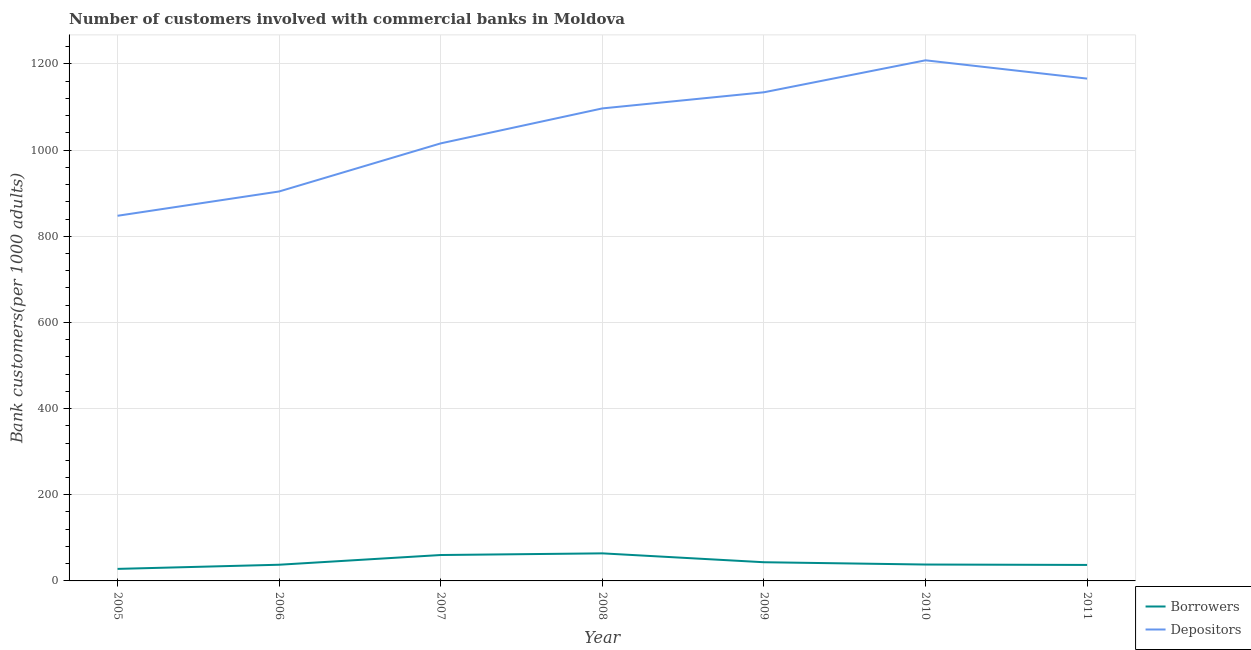How many different coloured lines are there?
Offer a terse response. 2. Does the line corresponding to number of borrowers intersect with the line corresponding to number of depositors?
Ensure brevity in your answer.  No. Is the number of lines equal to the number of legend labels?
Offer a very short reply. Yes. What is the number of borrowers in 2006?
Your answer should be very brief. 37.56. Across all years, what is the maximum number of borrowers?
Ensure brevity in your answer.  63.99. Across all years, what is the minimum number of borrowers?
Your answer should be very brief. 27.94. In which year was the number of depositors maximum?
Provide a short and direct response. 2010. What is the total number of borrowers in the graph?
Your response must be concise. 308.14. What is the difference between the number of depositors in 2007 and that in 2011?
Your response must be concise. -150.33. What is the difference between the number of borrowers in 2006 and the number of depositors in 2008?
Your response must be concise. -1059.17. What is the average number of borrowers per year?
Provide a succinct answer. 44.02. In the year 2007, what is the difference between the number of borrowers and number of depositors?
Your response must be concise. -955.47. In how many years, is the number of depositors greater than 520?
Provide a succinct answer. 7. What is the ratio of the number of depositors in 2006 to that in 2007?
Offer a terse response. 0.89. Is the number of depositors in 2009 less than that in 2010?
Offer a terse response. Yes. Is the difference between the number of borrowers in 2005 and 2010 greater than the difference between the number of depositors in 2005 and 2010?
Your answer should be compact. Yes. What is the difference between the highest and the second highest number of depositors?
Provide a short and direct response. 42.46. What is the difference between the highest and the lowest number of borrowers?
Make the answer very short. 36.05. In how many years, is the number of depositors greater than the average number of depositors taken over all years?
Ensure brevity in your answer.  4. Is the sum of the number of depositors in 2008 and 2010 greater than the maximum number of borrowers across all years?
Ensure brevity in your answer.  Yes. Does the number of depositors monotonically increase over the years?
Offer a terse response. No. Is the number of depositors strictly greater than the number of borrowers over the years?
Offer a very short reply. Yes. Is the number of depositors strictly less than the number of borrowers over the years?
Offer a terse response. No. How many lines are there?
Your response must be concise. 2. Does the graph contain grids?
Your response must be concise. Yes. Where does the legend appear in the graph?
Make the answer very short. Bottom right. How many legend labels are there?
Provide a short and direct response. 2. How are the legend labels stacked?
Your response must be concise. Vertical. What is the title of the graph?
Offer a very short reply. Number of customers involved with commercial banks in Moldova. What is the label or title of the X-axis?
Your response must be concise. Year. What is the label or title of the Y-axis?
Provide a short and direct response. Bank customers(per 1000 adults). What is the Bank customers(per 1000 adults) in Borrowers in 2005?
Make the answer very short. 27.94. What is the Bank customers(per 1000 adults) of Depositors in 2005?
Give a very brief answer. 847.53. What is the Bank customers(per 1000 adults) of Borrowers in 2006?
Offer a very short reply. 37.56. What is the Bank customers(per 1000 adults) in Depositors in 2006?
Your answer should be very brief. 903.95. What is the Bank customers(per 1000 adults) in Borrowers in 2007?
Offer a very short reply. 60.13. What is the Bank customers(per 1000 adults) in Depositors in 2007?
Your answer should be compact. 1015.6. What is the Bank customers(per 1000 adults) in Borrowers in 2008?
Your response must be concise. 63.99. What is the Bank customers(per 1000 adults) of Depositors in 2008?
Offer a terse response. 1096.73. What is the Bank customers(per 1000 adults) of Borrowers in 2009?
Your answer should be compact. 43.38. What is the Bank customers(per 1000 adults) in Depositors in 2009?
Your response must be concise. 1134.17. What is the Bank customers(per 1000 adults) in Borrowers in 2010?
Make the answer very short. 38.03. What is the Bank customers(per 1000 adults) in Depositors in 2010?
Make the answer very short. 1208.39. What is the Bank customers(per 1000 adults) in Borrowers in 2011?
Offer a terse response. 37.11. What is the Bank customers(per 1000 adults) in Depositors in 2011?
Offer a terse response. 1165.93. Across all years, what is the maximum Bank customers(per 1000 adults) in Borrowers?
Offer a very short reply. 63.99. Across all years, what is the maximum Bank customers(per 1000 adults) in Depositors?
Keep it short and to the point. 1208.39. Across all years, what is the minimum Bank customers(per 1000 adults) in Borrowers?
Provide a succinct answer. 27.94. Across all years, what is the minimum Bank customers(per 1000 adults) in Depositors?
Give a very brief answer. 847.53. What is the total Bank customers(per 1000 adults) in Borrowers in the graph?
Provide a succinct answer. 308.14. What is the total Bank customers(per 1000 adults) of Depositors in the graph?
Offer a terse response. 7372.31. What is the difference between the Bank customers(per 1000 adults) of Borrowers in 2005 and that in 2006?
Your answer should be very brief. -9.62. What is the difference between the Bank customers(per 1000 adults) of Depositors in 2005 and that in 2006?
Offer a terse response. -56.41. What is the difference between the Bank customers(per 1000 adults) in Borrowers in 2005 and that in 2007?
Your answer should be very brief. -32.2. What is the difference between the Bank customers(per 1000 adults) in Depositors in 2005 and that in 2007?
Your response must be concise. -168.07. What is the difference between the Bank customers(per 1000 adults) in Borrowers in 2005 and that in 2008?
Your answer should be compact. -36.05. What is the difference between the Bank customers(per 1000 adults) of Depositors in 2005 and that in 2008?
Your answer should be very brief. -249.19. What is the difference between the Bank customers(per 1000 adults) in Borrowers in 2005 and that in 2009?
Offer a terse response. -15.44. What is the difference between the Bank customers(per 1000 adults) of Depositors in 2005 and that in 2009?
Ensure brevity in your answer.  -286.64. What is the difference between the Bank customers(per 1000 adults) of Borrowers in 2005 and that in 2010?
Offer a terse response. -10.1. What is the difference between the Bank customers(per 1000 adults) of Depositors in 2005 and that in 2010?
Provide a succinct answer. -360.86. What is the difference between the Bank customers(per 1000 adults) in Borrowers in 2005 and that in 2011?
Your answer should be very brief. -9.18. What is the difference between the Bank customers(per 1000 adults) of Depositors in 2005 and that in 2011?
Your answer should be very brief. -318.4. What is the difference between the Bank customers(per 1000 adults) in Borrowers in 2006 and that in 2007?
Your answer should be very brief. -22.58. What is the difference between the Bank customers(per 1000 adults) in Depositors in 2006 and that in 2007?
Provide a succinct answer. -111.65. What is the difference between the Bank customers(per 1000 adults) of Borrowers in 2006 and that in 2008?
Provide a succinct answer. -26.43. What is the difference between the Bank customers(per 1000 adults) in Depositors in 2006 and that in 2008?
Your answer should be compact. -192.78. What is the difference between the Bank customers(per 1000 adults) in Borrowers in 2006 and that in 2009?
Your answer should be very brief. -5.82. What is the difference between the Bank customers(per 1000 adults) in Depositors in 2006 and that in 2009?
Make the answer very short. -230.23. What is the difference between the Bank customers(per 1000 adults) in Borrowers in 2006 and that in 2010?
Ensure brevity in your answer.  -0.48. What is the difference between the Bank customers(per 1000 adults) in Depositors in 2006 and that in 2010?
Provide a succinct answer. -304.44. What is the difference between the Bank customers(per 1000 adults) of Borrowers in 2006 and that in 2011?
Offer a terse response. 0.44. What is the difference between the Bank customers(per 1000 adults) of Depositors in 2006 and that in 2011?
Ensure brevity in your answer.  -261.98. What is the difference between the Bank customers(per 1000 adults) in Borrowers in 2007 and that in 2008?
Offer a terse response. -3.86. What is the difference between the Bank customers(per 1000 adults) of Depositors in 2007 and that in 2008?
Your answer should be very brief. -81.13. What is the difference between the Bank customers(per 1000 adults) in Borrowers in 2007 and that in 2009?
Your answer should be compact. 16.76. What is the difference between the Bank customers(per 1000 adults) in Depositors in 2007 and that in 2009?
Give a very brief answer. -118.57. What is the difference between the Bank customers(per 1000 adults) in Borrowers in 2007 and that in 2010?
Your response must be concise. 22.1. What is the difference between the Bank customers(per 1000 adults) in Depositors in 2007 and that in 2010?
Offer a very short reply. -192.79. What is the difference between the Bank customers(per 1000 adults) of Borrowers in 2007 and that in 2011?
Give a very brief answer. 23.02. What is the difference between the Bank customers(per 1000 adults) of Depositors in 2007 and that in 2011?
Your response must be concise. -150.33. What is the difference between the Bank customers(per 1000 adults) of Borrowers in 2008 and that in 2009?
Offer a very short reply. 20.61. What is the difference between the Bank customers(per 1000 adults) in Depositors in 2008 and that in 2009?
Ensure brevity in your answer.  -37.44. What is the difference between the Bank customers(per 1000 adults) of Borrowers in 2008 and that in 2010?
Provide a succinct answer. 25.95. What is the difference between the Bank customers(per 1000 adults) in Depositors in 2008 and that in 2010?
Keep it short and to the point. -111.66. What is the difference between the Bank customers(per 1000 adults) in Borrowers in 2008 and that in 2011?
Your response must be concise. 26.87. What is the difference between the Bank customers(per 1000 adults) in Depositors in 2008 and that in 2011?
Make the answer very short. -69.2. What is the difference between the Bank customers(per 1000 adults) of Borrowers in 2009 and that in 2010?
Provide a succinct answer. 5.34. What is the difference between the Bank customers(per 1000 adults) of Depositors in 2009 and that in 2010?
Offer a very short reply. -74.22. What is the difference between the Bank customers(per 1000 adults) of Borrowers in 2009 and that in 2011?
Ensure brevity in your answer.  6.26. What is the difference between the Bank customers(per 1000 adults) in Depositors in 2009 and that in 2011?
Make the answer very short. -31.76. What is the difference between the Bank customers(per 1000 adults) of Borrowers in 2010 and that in 2011?
Give a very brief answer. 0.92. What is the difference between the Bank customers(per 1000 adults) of Depositors in 2010 and that in 2011?
Keep it short and to the point. 42.46. What is the difference between the Bank customers(per 1000 adults) in Borrowers in 2005 and the Bank customers(per 1000 adults) in Depositors in 2006?
Your answer should be very brief. -876.01. What is the difference between the Bank customers(per 1000 adults) of Borrowers in 2005 and the Bank customers(per 1000 adults) of Depositors in 2007?
Your answer should be compact. -987.66. What is the difference between the Bank customers(per 1000 adults) of Borrowers in 2005 and the Bank customers(per 1000 adults) of Depositors in 2008?
Your answer should be compact. -1068.79. What is the difference between the Bank customers(per 1000 adults) of Borrowers in 2005 and the Bank customers(per 1000 adults) of Depositors in 2009?
Offer a very short reply. -1106.24. What is the difference between the Bank customers(per 1000 adults) in Borrowers in 2005 and the Bank customers(per 1000 adults) in Depositors in 2010?
Keep it short and to the point. -1180.45. What is the difference between the Bank customers(per 1000 adults) in Borrowers in 2005 and the Bank customers(per 1000 adults) in Depositors in 2011?
Provide a succinct answer. -1137.99. What is the difference between the Bank customers(per 1000 adults) in Borrowers in 2006 and the Bank customers(per 1000 adults) in Depositors in 2007?
Your response must be concise. -978.04. What is the difference between the Bank customers(per 1000 adults) of Borrowers in 2006 and the Bank customers(per 1000 adults) of Depositors in 2008?
Give a very brief answer. -1059.17. What is the difference between the Bank customers(per 1000 adults) in Borrowers in 2006 and the Bank customers(per 1000 adults) in Depositors in 2009?
Keep it short and to the point. -1096.62. What is the difference between the Bank customers(per 1000 adults) in Borrowers in 2006 and the Bank customers(per 1000 adults) in Depositors in 2010?
Your answer should be very brief. -1170.83. What is the difference between the Bank customers(per 1000 adults) of Borrowers in 2006 and the Bank customers(per 1000 adults) of Depositors in 2011?
Provide a succinct answer. -1128.37. What is the difference between the Bank customers(per 1000 adults) of Borrowers in 2007 and the Bank customers(per 1000 adults) of Depositors in 2008?
Make the answer very short. -1036.6. What is the difference between the Bank customers(per 1000 adults) of Borrowers in 2007 and the Bank customers(per 1000 adults) of Depositors in 2009?
Keep it short and to the point. -1074.04. What is the difference between the Bank customers(per 1000 adults) of Borrowers in 2007 and the Bank customers(per 1000 adults) of Depositors in 2010?
Give a very brief answer. -1148.26. What is the difference between the Bank customers(per 1000 adults) in Borrowers in 2007 and the Bank customers(per 1000 adults) in Depositors in 2011?
Offer a very short reply. -1105.8. What is the difference between the Bank customers(per 1000 adults) of Borrowers in 2008 and the Bank customers(per 1000 adults) of Depositors in 2009?
Your answer should be very brief. -1070.19. What is the difference between the Bank customers(per 1000 adults) in Borrowers in 2008 and the Bank customers(per 1000 adults) in Depositors in 2010?
Your answer should be compact. -1144.4. What is the difference between the Bank customers(per 1000 adults) of Borrowers in 2008 and the Bank customers(per 1000 adults) of Depositors in 2011?
Your answer should be very brief. -1101.94. What is the difference between the Bank customers(per 1000 adults) of Borrowers in 2009 and the Bank customers(per 1000 adults) of Depositors in 2010?
Your answer should be compact. -1165.01. What is the difference between the Bank customers(per 1000 adults) in Borrowers in 2009 and the Bank customers(per 1000 adults) in Depositors in 2011?
Provide a short and direct response. -1122.55. What is the difference between the Bank customers(per 1000 adults) of Borrowers in 2010 and the Bank customers(per 1000 adults) of Depositors in 2011?
Your response must be concise. -1127.9. What is the average Bank customers(per 1000 adults) of Borrowers per year?
Ensure brevity in your answer.  44.02. What is the average Bank customers(per 1000 adults) of Depositors per year?
Your answer should be very brief. 1053.19. In the year 2005, what is the difference between the Bank customers(per 1000 adults) of Borrowers and Bank customers(per 1000 adults) of Depositors?
Keep it short and to the point. -819.6. In the year 2006, what is the difference between the Bank customers(per 1000 adults) of Borrowers and Bank customers(per 1000 adults) of Depositors?
Ensure brevity in your answer.  -866.39. In the year 2007, what is the difference between the Bank customers(per 1000 adults) in Borrowers and Bank customers(per 1000 adults) in Depositors?
Keep it short and to the point. -955.47. In the year 2008, what is the difference between the Bank customers(per 1000 adults) of Borrowers and Bank customers(per 1000 adults) of Depositors?
Your answer should be very brief. -1032.74. In the year 2009, what is the difference between the Bank customers(per 1000 adults) of Borrowers and Bank customers(per 1000 adults) of Depositors?
Your answer should be very brief. -1090.8. In the year 2010, what is the difference between the Bank customers(per 1000 adults) of Borrowers and Bank customers(per 1000 adults) of Depositors?
Your answer should be compact. -1170.36. In the year 2011, what is the difference between the Bank customers(per 1000 adults) in Borrowers and Bank customers(per 1000 adults) in Depositors?
Provide a succinct answer. -1128.82. What is the ratio of the Bank customers(per 1000 adults) of Borrowers in 2005 to that in 2006?
Offer a very short reply. 0.74. What is the ratio of the Bank customers(per 1000 adults) in Depositors in 2005 to that in 2006?
Provide a succinct answer. 0.94. What is the ratio of the Bank customers(per 1000 adults) in Borrowers in 2005 to that in 2007?
Provide a short and direct response. 0.46. What is the ratio of the Bank customers(per 1000 adults) of Depositors in 2005 to that in 2007?
Give a very brief answer. 0.83. What is the ratio of the Bank customers(per 1000 adults) of Borrowers in 2005 to that in 2008?
Provide a succinct answer. 0.44. What is the ratio of the Bank customers(per 1000 adults) in Depositors in 2005 to that in 2008?
Provide a short and direct response. 0.77. What is the ratio of the Bank customers(per 1000 adults) in Borrowers in 2005 to that in 2009?
Your answer should be compact. 0.64. What is the ratio of the Bank customers(per 1000 adults) in Depositors in 2005 to that in 2009?
Offer a terse response. 0.75. What is the ratio of the Bank customers(per 1000 adults) in Borrowers in 2005 to that in 2010?
Keep it short and to the point. 0.73. What is the ratio of the Bank customers(per 1000 adults) of Depositors in 2005 to that in 2010?
Offer a very short reply. 0.7. What is the ratio of the Bank customers(per 1000 adults) of Borrowers in 2005 to that in 2011?
Offer a very short reply. 0.75. What is the ratio of the Bank customers(per 1000 adults) in Depositors in 2005 to that in 2011?
Your response must be concise. 0.73. What is the ratio of the Bank customers(per 1000 adults) of Borrowers in 2006 to that in 2007?
Provide a short and direct response. 0.62. What is the ratio of the Bank customers(per 1000 adults) in Depositors in 2006 to that in 2007?
Provide a short and direct response. 0.89. What is the ratio of the Bank customers(per 1000 adults) of Borrowers in 2006 to that in 2008?
Ensure brevity in your answer.  0.59. What is the ratio of the Bank customers(per 1000 adults) in Depositors in 2006 to that in 2008?
Ensure brevity in your answer.  0.82. What is the ratio of the Bank customers(per 1000 adults) in Borrowers in 2006 to that in 2009?
Your response must be concise. 0.87. What is the ratio of the Bank customers(per 1000 adults) of Depositors in 2006 to that in 2009?
Your response must be concise. 0.8. What is the ratio of the Bank customers(per 1000 adults) of Borrowers in 2006 to that in 2010?
Ensure brevity in your answer.  0.99. What is the ratio of the Bank customers(per 1000 adults) of Depositors in 2006 to that in 2010?
Give a very brief answer. 0.75. What is the ratio of the Bank customers(per 1000 adults) in Borrowers in 2006 to that in 2011?
Provide a short and direct response. 1.01. What is the ratio of the Bank customers(per 1000 adults) in Depositors in 2006 to that in 2011?
Ensure brevity in your answer.  0.78. What is the ratio of the Bank customers(per 1000 adults) of Borrowers in 2007 to that in 2008?
Ensure brevity in your answer.  0.94. What is the ratio of the Bank customers(per 1000 adults) of Depositors in 2007 to that in 2008?
Provide a short and direct response. 0.93. What is the ratio of the Bank customers(per 1000 adults) in Borrowers in 2007 to that in 2009?
Provide a succinct answer. 1.39. What is the ratio of the Bank customers(per 1000 adults) of Depositors in 2007 to that in 2009?
Keep it short and to the point. 0.9. What is the ratio of the Bank customers(per 1000 adults) of Borrowers in 2007 to that in 2010?
Offer a very short reply. 1.58. What is the ratio of the Bank customers(per 1000 adults) of Depositors in 2007 to that in 2010?
Give a very brief answer. 0.84. What is the ratio of the Bank customers(per 1000 adults) of Borrowers in 2007 to that in 2011?
Ensure brevity in your answer.  1.62. What is the ratio of the Bank customers(per 1000 adults) of Depositors in 2007 to that in 2011?
Offer a terse response. 0.87. What is the ratio of the Bank customers(per 1000 adults) in Borrowers in 2008 to that in 2009?
Ensure brevity in your answer.  1.48. What is the ratio of the Bank customers(per 1000 adults) of Borrowers in 2008 to that in 2010?
Provide a short and direct response. 1.68. What is the ratio of the Bank customers(per 1000 adults) of Depositors in 2008 to that in 2010?
Offer a terse response. 0.91. What is the ratio of the Bank customers(per 1000 adults) of Borrowers in 2008 to that in 2011?
Provide a succinct answer. 1.72. What is the ratio of the Bank customers(per 1000 adults) of Depositors in 2008 to that in 2011?
Your answer should be very brief. 0.94. What is the ratio of the Bank customers(per 1000 adults) of Borrowers in 2009 to that in 2010?
Make the answer very short. 1.14. What is the ratio of the Bank customers(per 1000 adults) of Depositors in 2009 to that in 2010?
Make the answer very short. 0.94. What is the ratio of the Bank customers(per 1000 adults) of Borrowers in 2009 to that in 2011?
Provide a short and direct response. 1.17. What is the ratio of the Bank customers(per 1000 adults) of Depositors in 2009 to that in 2011?
Offer a terse response. 0.97. What is the ratio of the Bank customers(per 1000 adults) in Borrowers in 2010 to that in 2011?
Keep it short and to the point. 1.02. What is the ratio of the Bank customers(per 1000 adults) in Depositors in 2010 to that in 2011?
Ensure brevity in your answer.  1.04. What is the difference between the highest and the second highest Bank customers(per 1000 adults) of Borrowers?
Ensure brevity in your answer.  3.86. What is the difference between the highest and the second highest Bank customers(per 1000 adults) of Depositors?
Your response must be concise. 42.46. What is the difference between the highest and the lowest Bank customers(per 1000 adults) in Borrowers?
Make the answer very short. 36.05. What is the difference between the highest and the lowest Bank customers(per 1000 adults) in Depositors?
Your answer should be compact. 360.86. 